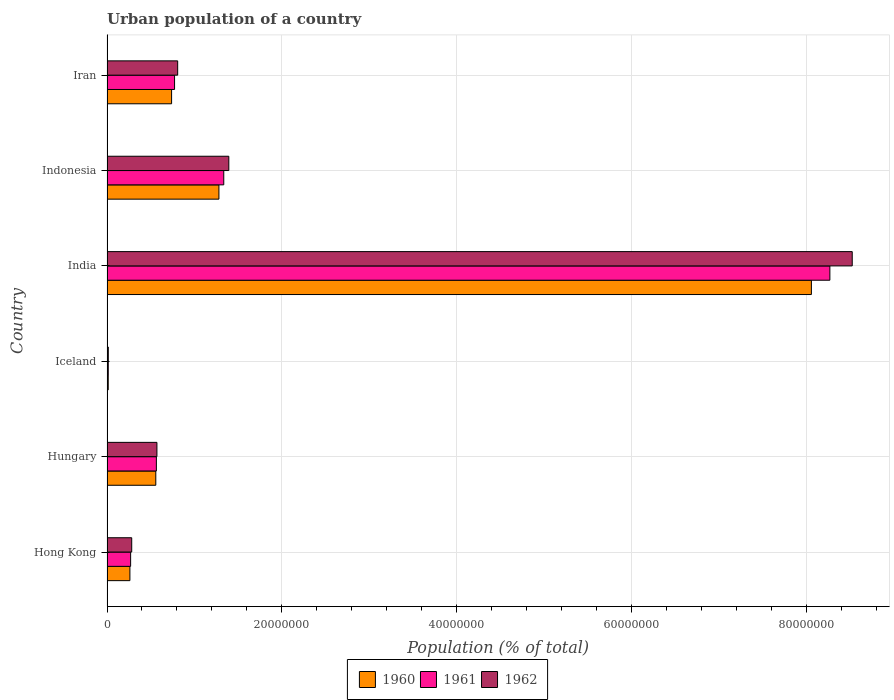How many different coloured bars are there?
Your answer should be very brief. 3. How many groups of bars are there?
Give a very brief answer. 6. Are the number of bars per tick equal to the number of legend labels?
Your answer should be very brief. Yes. Are the number of bars on each tick of the Y-axis equal?
Provide a short and direct response. Yes. How many bars are there on the 5th tick from the bottom?
Your answer should be compact. 3. What is the label of the 2nd group of bars from the top?
Provide a succinct answer. Indonesia. In how many cases, is the number of bars for a given country not equal to the number of legend labels?
Offer a terse response. 0. What is the urban population in 1960 in India?
Give a very brief answer. 8.06e+07. Across all countries, what is the maximum urban population in 1961?
Ensure brevity in your answer.  8.27e+07. Across all countries, what is the minimum urban population in 1962?
Offer a terse response. 1.48e+05. In which country was the urban population in 1960 maximum?
Ensure brevity in your answer.  India. In which country was the urban population in 1960 minimum?
Your answer should be compact. Iceland. What is the total urban population in 1962 in the graph?
Offer a terse response. 1.16e+08. What is the difference between the urban population in 1960 in Iceland and that in India?
Your answer should be compact. -8.05e+07. What is the difference between the urban population in 1960 in Hungary and the urban population in 1961 in Indonesia?
Keep it short and to the point. -7.78e+06. What is the average urban population in 1961 per country?
Offer a terse response. 1.87e+07. What is the difference between the urban population in 1961 and urban population in 1960 in India?
Keep it short and to the point. 2.11e+06. What is the ratio of the urban population in 1962 in Hong Kong to that in Iceland?
Your response must be concise. 19.08. What is the difference between the highest and the second highest urban population in 1960?
Give a very brief answer. 6.78e+07. What is the difference between the highest and the lowest urban population in 1961?
Ensure brevity in your answer.  8.26e+07. In how many countries, is the urban population in 1961 greater than the average urban population in 1961 taken over all countries?
Provide a short and direct response. 1. What does the 1st bar from the top in Iceland represents?
Provide a short and direct response. 1962. What does the 1st bar from the bottom in Iceland represents?
Ensure brevity in your answer.  1960. Is it the case that in every country, the sum of the urban population in 1962 and urban population in 1961 is greater than the urban population in 1960?
Your answer should be compact. Yes. How many bars are there?
Your response must be concise. 18. Are all the bars in the graph horizontal?
Provide a short and direct response. Yes. What is the difference between two consecutive major ticks on the X-axis?
Ensure brevity in your answer.  2.00e+07. What is the title of the graph?
Offer a very short reply. Urban population of a country. What is the label or title of the X-axis?
Give a very brief answer. Population (% of total). What is the label or title of the Y-axis?
Offer a terse response. Country. What is the Population (% of total) of 1960 in Hong Kong?
Give a very brief answer. 2.62e+06. What is the Population (% of total) of 1961 in Hong Kong?
Your answer should be compact. 2.70e+06. What is the Population (% of total) of 1962 in Hong Kong?
Provide a succinct answer. 2.83e+06. What is the Population (% of total) of 1960 in Hungary?
Give a very brief answer. 5.58e+06. What is the Population (% of total) of 1961 in Hungary?
Your answer should be very brief. 5.65e+06. What is the Population (% of total) of 1962 in Hungary?
Your answer should be very brief. 5.71e+06. What is the Population (% of total) in 1960 in Iceland?
Provide a short and direct response. 1.41e+05. What is the Population (% of total) in 1961 in Iceland?
Provide a short and direct response. 1.45e+05. What is the Population (% of total) in 1962 in Iceland?
Your response must be concise. 1.48e+05. What is the Population (% of total) of 1960 in India?
Give a very brief answer. 8.06e+07. What is the Population (% of total) in 1961 in India?
Keep it short and to the point. 8.27e+07. What is the Population (% of total) in 1962 in India?
Offer a terse response. 8.53e+07. What is the Population (% of total) of 1960 in Indonesia?
Make the answer very short. 1.28e+07. What is the Population (% of total) in 1961 in Indonesia?
Provide a short and direct response. 1.34e+07. What is the Population (% of total) in 1962 in Indonesia?
Provide a succinct answer. 1.39e+07. What is the Population (% of total) in 1960 in Iran?
Provide a succinct answer. 7.39e+06. What is the Population (% of total) of 1961 in Iran?
Make the answer very short. 7.73e+06. What is the Population (% of total) of 1962 in Iran?
Give a very brief answer. 8.09e+06. Across all countries, what is the maximum Population (% of total) of 1960?
Ensure brevity in your answer.  8.06e+07. Across all countries, what is the maximum Population (% of total) of 1961?
Your answer should be very brief. 8.27e+07. Across all countries, what is the maximum Population (% of total) of 1962?
Give a very brief answer. 8.53e+07. Across all countries, what is the minimum Population (% of total) in 1960?
Keep it short and to the point. 1.41e+05. Across all countries, what is the minimum Population (% of total) of 1961?
Your answer should be compact. 1.45e+05. Across all countries, what is the minimum Population (% of total) of 1962?
Provide a short and direct response. 1.48e+05. What is the total Population (% of total) in 1960 in the graph?
Give a very brief answer. 1.09e+08. What is the total Population (% of total) of 1961 in the graph?
Your answer should be very brief. 1.12e+08. What is the total Population (% of total) of 1962 in the graph?
Your answer should be compact. 1.16e+08. What is the difference between the Population (% of total) of 1960 in Hong Kong and that in Hungary?
Ensure brevity in your answer.  -2.96e+06. What is the difference between the Population (% of total) of 1961 in Hong Kong and that in Hungary?
Your response must be concise. -2.95e+06. What is the difference between the Population (% of total) in 1962 in Hong Kong and that in Hungary?
Ensure brevity in your answer.  -2.88e+06. What is the difference between the Population (% of total) of 1960 in Hong Kong and that in Iceland?
Give a very brief answer. 2.48e+06. What is the difference between the Population (% of total) in 1961 in Hong Kong and that in Iceland?
Give a very brief answer. 2.56e+06. What is the difference between the Population (% of total) in 1962 in Hong Kong and that in Iceland?
Offer a terse response. 2.68e+06. What is the difference between the Population (% of total) of 1960 in Hong Kong and that in India?
Give a very brief answer. -7.80e+07. What is the difference between the Population (% of total) in 1961 in Hong Kong and that in India?
Make the answer very short. -8.00e+07. What is the difference between the Population (% of total) in 1962 in Hong Kong and that in India?
Your response must be concise. -8.24e+07. What is the difference between the Population (% of total) of 1960 in Hong Kong and that in Indonesia?
Keep it short and to the point. -1.02e+07. What is the difference between the Population (% of total) in 1961 in Hong Kong and that in Indonesia?
Offer a very short reply. -1.07e+07. What is the difference between the Population (% of total) of 1962 in Hong Kong and that in Indonesia?
Offer a very short reply. -1.11e+07. What is the difference between the Population (% of total) of 1960 in Hong Kong and that in Iran?
Your answer should be compact. -4.77e+06. What is the difference between the Population (% of total) of 1961 in Hong Kong and that in Iran?
Give a very brief answer. -5.03e+06. What is the difference between the Population (% of total) of 1962 in Hong Kong and that in Iran?
Provide a short and direct response. -5.26e+06. What is the difference between the Population (% of total) of 1960 in Hungary and that in Iceland?
Offer a very short reply. 5.44e+06. What is the difference between the Population (% of total) of 1961 in Hungary and that in Iceland?
Offer a very short reply. 5.51e+06. What is the difference between the Population (% of total) of 1962 in Hungary and that in Iceland?
Provide a short and direct response. 5.56e+06. What is the difference between the Population (% of total) of 1960 in Hungary and that in India?
Provide a succinct answer. -7.50e+07. What is the difference between the Population (% of total) in 1961 in Hungary and that in India?
Offer a very short reply. -7.71e+07. What is the difference between the Population (% of total) in 1962 in Hungary and that in India?
Offer a terse response. -7.96e+07. What is the difference between the Population (% of total) of 1960 in Hungary and that in Indonesia?
Keep it short and to the point. -7.22e+06. What is the difference between the Population (% of total) of 1961 in Hungary and that in Indonesia?
Give a very brief answer. -7.71e+06. What is the difference between the Population (% of total) in 1962 in Hungary and that in Indonesia?
Your response must be concise. -8.23e+06. What is the difference between the Population (% of total) in 1960 in Hungary and that in Iran?
Offer a terse response. -1.81e+06. What is the difference between the Population (% of total) of 1961 in Hungary and that in Iran?
Your answer should be compact. -2.08e+06. What is the difference between the Population (% of total) of 1962 in Hungary and that in Iran?
Your response must be concise. -2.38e+06. What is the difference between the Population (% of total) of 1960 in Iceland and that in India?
Your answer should be very brief. -8.05e+07. What is the difference between the Population (% of total) of 1961 in Iceland and that in India?
Provide a short and direct response. -8.26e+07. What is the difference between the Population (% of total) in 1962 in Iceland and that in India?
Provide a short and direct response. -8.51e+07. What is the difference between the Population (% of total) in 1960 in Iceland and that in Indonesia?
Your response must be concise. -1.27e+07. What is the difference between the Population (% of total) in 1961 in Iceland and that in Indonesia?
Give a very brief answer. -1.32e+07. What is the difference between the Population (% of total) in 1962 in Iceland and that in Indonesia?
Make the answer very short. -1.38e+07. What is the difference between the Population (% of total) of 1960 in Iceland and that in Iran?
Your response must be concise. -7.25e+06. What is the difference between the Population (% of total) in 1961 in Iceland and that in Iran?
Your response must be concise. -7.59e+06. What is the difference between the Population (% of total) in 1962 in Iceland and that in Iran?
Provide a short and direct response. -7.94e+06. What is the difference between the Population (% of total) in 1960 in India and that in Indonesia?
Your response must be concise. 6.78e+07. What is the difference between the Population (% of total) of 1961 in India and that in Indonesia?
Provide a short and direct response. 6.94e+07. What is the difference between the Population (% of total) in 1962 in India and that in Indonesia?
Provide a short and direct response. 7.13e+07. What is the difference between the Population (% of total) of 1960 in India and that in Iran?
Give a very brief answer. 7.32e+07. What is the difference between the Population (% of total) in 1961 in India and that in Iran?
Provide a short and direct response. 7.50e+07. What is the difference between the Population (% of total) in 1962 in India and that in Iran?
Provide a succinct answer. 7.72e+07. What is the difference between the Population (% of total) in 1960 in Indonesia and that in Iran?
Ensure brevity in your answer.  5.42e+06. What is the difference between the Population (% of total) of 1961 in Indonesia and that in Iran?
Make the answer very short. 5.63e+06. What is the difference between the Population (% of total) in 1962 in Indonesia and that in Iran?
Your answer should be very brief. 5.85e+06. What is the difference between the Population (% of total) in 1960 in Hong Kong and the Population (% of total) in 1961 in Hungary?
Give a very brief answer. -3.03e+06. What is the difference between the Population (% of total) of 1960 in Hong Kong and the Population (% of total) of 1962 in Hungary?
Provide a succinct answer. -3.09e+06. What is the difference between the Population (% of total) of 1961 in Hong Kong and the Population (% of total) of 1962 in Hungary?
Offer a terse response. -3.01e+06. What is the difference between the Population (% of total) in 1960 in Hong Kong and the Population (% of total) in 1961 in Iceland?
Provide a short and direct response. 2.48e+06. What is the difference between the Population (% of total) of 1960 in Hong Kong and the Population (% of total) of 1962 in Iceland?
Ensure brevity in your answer.  2.47e+06. What is the difference between the Population (% of total) in 1961 in Hong Kong and the Population (% of total) in 1962 in Iceland?
Provide a succinct answer. 2.55e+06. What is the difference between the Population (% of total) in 1960 in Hong Kong and the Population (% of total) in 1961 in India?
Keep it short and to the point. -8.01e+07. What is the difference between the Population (% of total) in 1960 in Hong Kong and the Population (% of total) in 1962 in India?
Your response must be concise. -8.26e+07. What is the difference between the Population (% of total) of 1961 in Hong Kong and the Population (% of total) of 1962 in India?
Make the answer very short. -8.26e+07. What is the difference between the Population (% of total) in 1960 in Hong Kong and the Population (% of total) in 1961 in Indonesia?
Ensure brevity in your answer.  -1.07e+07. What is the difference between the Population (% of total) of 1960 in Hong Kong and the Population (% of total) of 1962 in Indonesia?
Your answer should be very brief. -1.13e+07. What is the difference between the Population (% of total) in 1961 in Hong Kong and the Population (% of total) in 1962 in Indonesia?
Keep it short and to the point. -1.12e+07. What is the difference between the Population (% of total) of 1960 in Hong Kong and the Population (% of total) of 1961 in Iran?
Your answer should be very brief. -5.11e+06. What is the difference between the Population (% of total) of 1960 in Hong Kong and the Population (% of total) of 1962 in Iran?
Your answer should be compact. -5.47e+06. What is the difference between the Population (% of total) in 1961 in Hong Kong and the Population (% of total) in 1962 in Iran?
Your response must be concise. -5.38e+06. What is the difference between the Population (% of total) in 1960 in Hungary and the Population (% of total) in 1961 in Iceland?
Offer a terse response. 5.44e+06. What is the difference between the Population (% of total) in 1960 in Hungary and the Population (% of total) in 1962 in Iceland?
Ensure brevity in your answer.  5.43e+06. What is the difference between the Population (% of total) of 1961 in Hungary and the Population (% of total) of 1962 in Iceland?
Your answer should be compact. 5.50e+06. What is the difference between the Population (% of total) of 1960 in Hungary and the Population (% of total) of 1961 in India?
Provide a short and direct response. -7.71e+07. What is the difference between the Population (% of total) in 1960 in Hungary and the Population (% of total) in 1962 in India?
Offer a very short reply. -7.97e+07. What is the difference between the Population (% of total) of 1961 in Hungary and the Population (% of total) of 1962 in India?
Make the answer very short. -7.96e+07. What is the difference between the Population (% of total) of 1960 in Hungary and the Population (% of total) of 1961 in Indonesia?
Your answer should be compact. -7.78e+06. What is the difference between the Population (% of total) in 1960 in Hungary and the Population (% of total) in 1962 in Indonesia?
Make the answer very short. -8.36e+06. What is the difference between the Population (% of total) of 1961 in Hungary and the Population (% of total) of 1962 in Indonesia?
Offer a terse response. -8.29e+06. What is the difference between the Population (% of total) in 1960 in Hungary and the Population (% of total) in 1961 in Iran?
Your answer should be compact. -2.15e+06. What is the difference between the Population (% of total) in 1960 in Hungary and the Population (% of total) in 1962 in Iran?
Make the answer very short. -2.50e+06. What is the difference between the Population (% of total) of 1961 in Hungary and the Population (% of total) of 1962 in Iran?
Provide a succinct answer. -2.44e+06. What is the difference between the Population (% of total) of 1960 in Iceland and the Population (% of total) of 1961 in India?
Give a very brief answer. -8.26e+07. What is the difference between the Population (% of total) of 1960 in Iceland and the Population (% of total) of 1962 in India?
Give a very brief answer. -8.51e+07. What is the difference between the Population (% of total) in 1961 in Iceland and the Population (% of total) in 1962 in India?
Your answer should be very brief. -8.51e+07. What is the difference between the Population (% of total) in 1960 in Iceland and the Population (% of total) in 1961 in Indonesia?
Make the answer very short. -1.32e+07. What is the difference between the Population (% of total) of 1960 in Iceland and the Population (% of total) of 1962 in Indonesia?
Keep it short and to the point. -1.38e+07. What is the difference between the Population (% of total) of 1961 in Iceland and the Population (% of total) of 1962 in Indonesia?
Offer a terse response. -1.38e+07. What is the difference between the Population (% of total) in 1960 in Iceland and the Population (% of total) in 1961 in Iran?
Your answer should be compact. -7.59e+06. What is the difference between the Population (% of total) of 1960 in Iceland and the Population (% of total) of 1962 in Iran?
Offer a very short reply. -7.95e+06. What is the difference between the Population (% of total) in 1961 in Iceland and the Population (% of total) in 1962 in Iran?
Keep it short and to the point. -7.94e+06. What is the difference between the Population (% of total) in 1960 in India and the Population (% of total) in 1961 in Indonesia?
Make the answer very short. 6.72e+07. What is the difference between the Population (% of total) in 1960 in India and the Population (% of total) in 1962 in Indonesia?
Your answer should be very brief. 6.67e+07. What is the difference between the Population (% of total) in 1961 in India and the Population (% of total) in 1962 in Indonesia?
Your answer should be very brief. 6.88e+07. What is the difference between the Population (% of total) in 1960 in India and the Population (% of total) in 1961 in Iran?
Offer a very short reply. 7.29e+07. What is the difference between the Population (% of total) of 1960 in India and the Population (% of total) of 1962 in Iran?
Provide a short and direct response. 7.25e+07. What is the difference between the Population (% of total) of 1961 in India and the Population (% of total) of 1962 in Iran?
Give a very brief answer. 7.46e+07. What is the difference between the Population (% of total) in 1960 in Indonesia and the Population (% of total) in 1961 in Iran?
Provide a succinct answer. 5.07e+06. What is the difference between the Population (% of total) of 1960 in Indonesia and the Population (% of total) of 1962 in Iran?
Ensure brevity in your answer.  4.72e+06. What is the difference between the Population (% of total) of 1961 in Indonesia and the Population (% of total) of 1962 in Iran?
Your answer should be very brief. 5.27e+06. What is the average Population (% of total) of 1960 per country?
Keep it short and to the point. 1.82e+07. What is the average Population (% of total) in 1961 per country?
Offer a terse response. 1.87e+07. What is the average Population (% of total) in 1962 per country?
Provide a short and direct response. 1.93e+07. What is the difference between the Population (% of total) of 1960 and Population (% of total) of 1961 in Hong Kong?
Provide a succinct answer. -8.18e+04. What is the difference between the Population (% of total) in 1960 and Population (% of total) in 1962 in Hong Kong?
Offer a terse response. -2.08e+05. What is the difference between the Population (% of total) in 1961 and Population (% of total) in 1962 in Hong Kong?
Provide a succinct answer. -1.26e+05. What is the difference between the Population (% of total) of 1960 and Population (% of total) of 1961 in Hungary?
Provide a short and direct response. -6.79e+04. What is the difference between the Population (% of total) of 1960 and Population (% of total) of 1962 in Hungary?
Ensure brevity in your answer.  -1.29e+05. What is the difference between the Population (% of total) of 1961 and Population (% of total) of 1962 in Hungary?
Offer a very short reply. -6.08e+04. What is the difference between the Population (% of total) in 1960 and Population (% of total) in 1961 in Iceland?
Keep it short and to the point. -3675. What is the difference between the Population (% of total) in 1960 and Population (% of total) in 1962 in Iceland?
Your answer should be compact. -7282. What is the difference between the Population (% of total) in 1961 and Population (% of total) in 1962 in Iceland?
Your response must be concise. -3607. What is the difference between the Population (% of total) of 1960 and Population (% of total) of 1961 in India?
Offer a terse response. -2.11e+06. What is the difference between the Population (% of total) in 1960 and Population (% of total) in 1962 in India?
Keep it short and to the point. -4.67e+06. What is the difference between the Population (% of total) of 1961 and Population (% of total) of 1962 in India?
Give a very brief answer. -2.56e+06. What is the difference between the Population (% of total) in 1960 and Population (% of total) in 1961 in Indonesia?
Keep it short and to the point. -5.54e+05. What is the difference between the Population (% of total) of 1960 and Population (% of total) of 1962 in Indonesia?
Provide a short and direct response. -1.13e+06. What is the difference between the Population (% of total) of 1961 and Population (% of total) of 1962 in Indonesia?
Keep it short and to the point. -5.78e+05. What is the difference between the Population (% of total) in 1960 and Population (% of total) in 1961 in Iran?
Your answer should be compact. -3.40e+05. What is the difference between the Population (% of total) in 1960 and Population (% of total) in 1962 in Iran?
Give a very brief answer. -6.96e+05. What is the difference between the Population (% of total) in 1961 and Population (% of total) in 1962 in Iran?
Provide a succinct answer. -3.56e+05. What is the ratio of the Population (% of total) in 1960 in Hong Kong to that in Hungary?
Offer a terse response. 0.47. What is the ratio of the Population (% of total) of 1961 in Hong Kong to that in Hungary?
Offer a very short reply. 0.48. What is the ratio of the Population (% of total) of 1962 in Hong Kong to that in Hungary?
Your response must be concise. 0.5. What is the ratio of the Population (% of total) in 1960 in Hong Kong to that in Iceland?
Give a very brief answer. 18.59. What is the ratio of the Population (% of total) in 1961 in Hong Kong to that in Iceland?
Your response must be concise. 18.68. What is the ratio of the Population (% of total) in 1962 in Hong Kong to that in Iceland?
Your answer should be compact. 19.08. What is the ratio of the Population (% of total) in 1960 in Hong Kong to that in India?
Give a very brief answer. 0.03. What is the ratio of the Population (% of total) of 1961 in Hong Kong to that in India?
Your response must be concise. 0.03. What is the ratio of the Population (% of total) of 1962 in Hong Kong to that in India?
Offer a terse response. 0.03. What is the ratio of the Population (% of total) of 1960 in Hong Kong to that in Indonesia?
Offer a very short reply. 0.2. What is the ratio of the Population (% of total) in 1961 in Hong Kong to that in Indonesia?
Your answer should be compact. 0.2. What is the ratio of the Population (% of total) in 1962 in Hong Kong to that in Indonesia?
Give a very brief answer. 0.2. What is the ratio of the Population (% of total) of 1960 in Hong Kong to that in Iran?
Keep it short and to the point. 0.35. What is the ratio of the Population (% of total) in 1961 in Hong Kong to that in Iran?
Provide a succinct answer. 0.35. What is the ratio of the Population (% of total) of 1962 in Hong Kong to that in Iran?
Your response must be concise. 0.35. What is the ratio of the Population (% of total) in 1960 in Hungary to that in Iceland?
Keep it short and to the point. 39.59. What is the ratio of the Population (% of total) of 1961 in Hungary to that in Iceland?
Provide a succinct answer. 39.06. What is the ratio of the Population (% of total) in 1962 in Hungary to that in Iceland?
Provide a succinct answer. 38.52. What is the ratio of the Population (% of total) of 1960 in Hungary to that in India?
Your answer should be very brief. 0.07. What is the ratio of the Population (% of total) in 1961 in Hungary to that in India?
Your answer should be compact. 0.07. What is the ratio of the Population (% of total) of 1962 in Hungary to that in India?
Your answer should be compact. 0.07. What is the ratio of the Population (% of total) in 1960 in Hungary to that in Indonesia?
Offer a very short reply. 0.44. What is the ratio of the Population (% of total) of 1961 in Hungary to that in Indonesia?
Give a very brief answer. 0.42. What is the ratio of the Population (% of total) in 1962 in Hungary to that in Indonesia?
Give a very brief answer. 0.41. What is the ratio of the Population (% of total) in 1960 in Hungary to that in Iran?
Provide a succinct answer. 0.76. What is the ratio of the Population (% of total) in 1961 in Hungary to that in Iran?
Your answer should be compact. 0.73. What is the ratio of the Population (% of total) in 1962 in Hungary to that in Iran?
Provide a short and direct response. 0.71. What is the ratio of the Population (% of total) in 1960 in Iceland to that in India?
Your response must be concise. 0. What is the ratio of the Population (% of total) of 1961 in Iceland to that in India?
Give a very brief answer. 0. What is the ratio of the Population (% of total) in 1962 in Iceland to that in India?
Offer a very short reply. 0. What is the ratio of the Population (% of total) in 1960 in Iceland to that in Indonesia?
Provide a succinct answer. 0.01. What is the ratio of the Population (% of total) in 1961 in Iceland to that in Indonesia?
Keep it short and to the point. 0.01. What is the ratio of the Population (% of total) in 1962 in Iceland to that in Indonesia?
Provide a short and direct response. 0.01. What is the ratio of the Population (% of total) in 1960 in Iceland to that in Iran?
Your answer should be very brief. 0.02. What is the ratio of the Population (% of total) of 1961 in Iceland to that in Iran?
Make the answer very short. 0.02. What is the ratio of the Population (% of total) of 1962 in Iceland to that in Iran?
Keep it short and to the point. 0.02. What is the ratio of the Population (% of total) of 1960 in India to that in Indonesia?
Keep it short and to the point. 6.29. What is the ratio of the Population (% of total) in 1961 in India to that in Indonesia?
Ensure brevity in your answer.  6.19. What is the ratio of the Population (% of total) of 1962 in India to that in Indonesia?
Provide a succinct answer. 6.12. What is the ratio of the Population (% of total) in 1960 in India to that in Iran?
Your response must be concise. 10.91. What is the ratio of the Population (% of total) of 1961 in India to that in Iran?
Provide a short and direct response. 10.7. What is the ratio of the Population (% of total) in 1962 in India to that in Iran?
Offer a terse response. 10.54. What is the ratio of the Population (% of total) in 1960 in Indonesia to that in Iran?
Provide a short and direct response. 1.73. What is the ratio of the Population (% of total) of 1961 in Indonesia to that in Iran?
Offer a very short reply. 1.73. What is the ratio of the Population (% of total) in 1962 in Indonesia to that in Iran?
Make the answer very short. 1.72. What is the difference between the highest and the second highest Population (% of total) of 1960?
Make the answer very short. 6.78e+07. What is the difference between the highest and the second highest Population (% of total) in 1961?
Provide a succinct answer. 6.94e+07. What is the difference between the highest and the second highest Population (% of total) of 1962?
Your answer should be compact. 7.13e+07. What is the difference between the highest and the lowest Population (% of total) of 1960?
Ensure brevity in your answer.  8.05e+07. What is the difference between the highest and the lowest Population (% of total) of 1961?
Provide a succinct answer. 8.26e+07. What is the difference between the highest and the lowest Population (% of total) of 1962?
Give a very brief answer. 8.51e+07. 